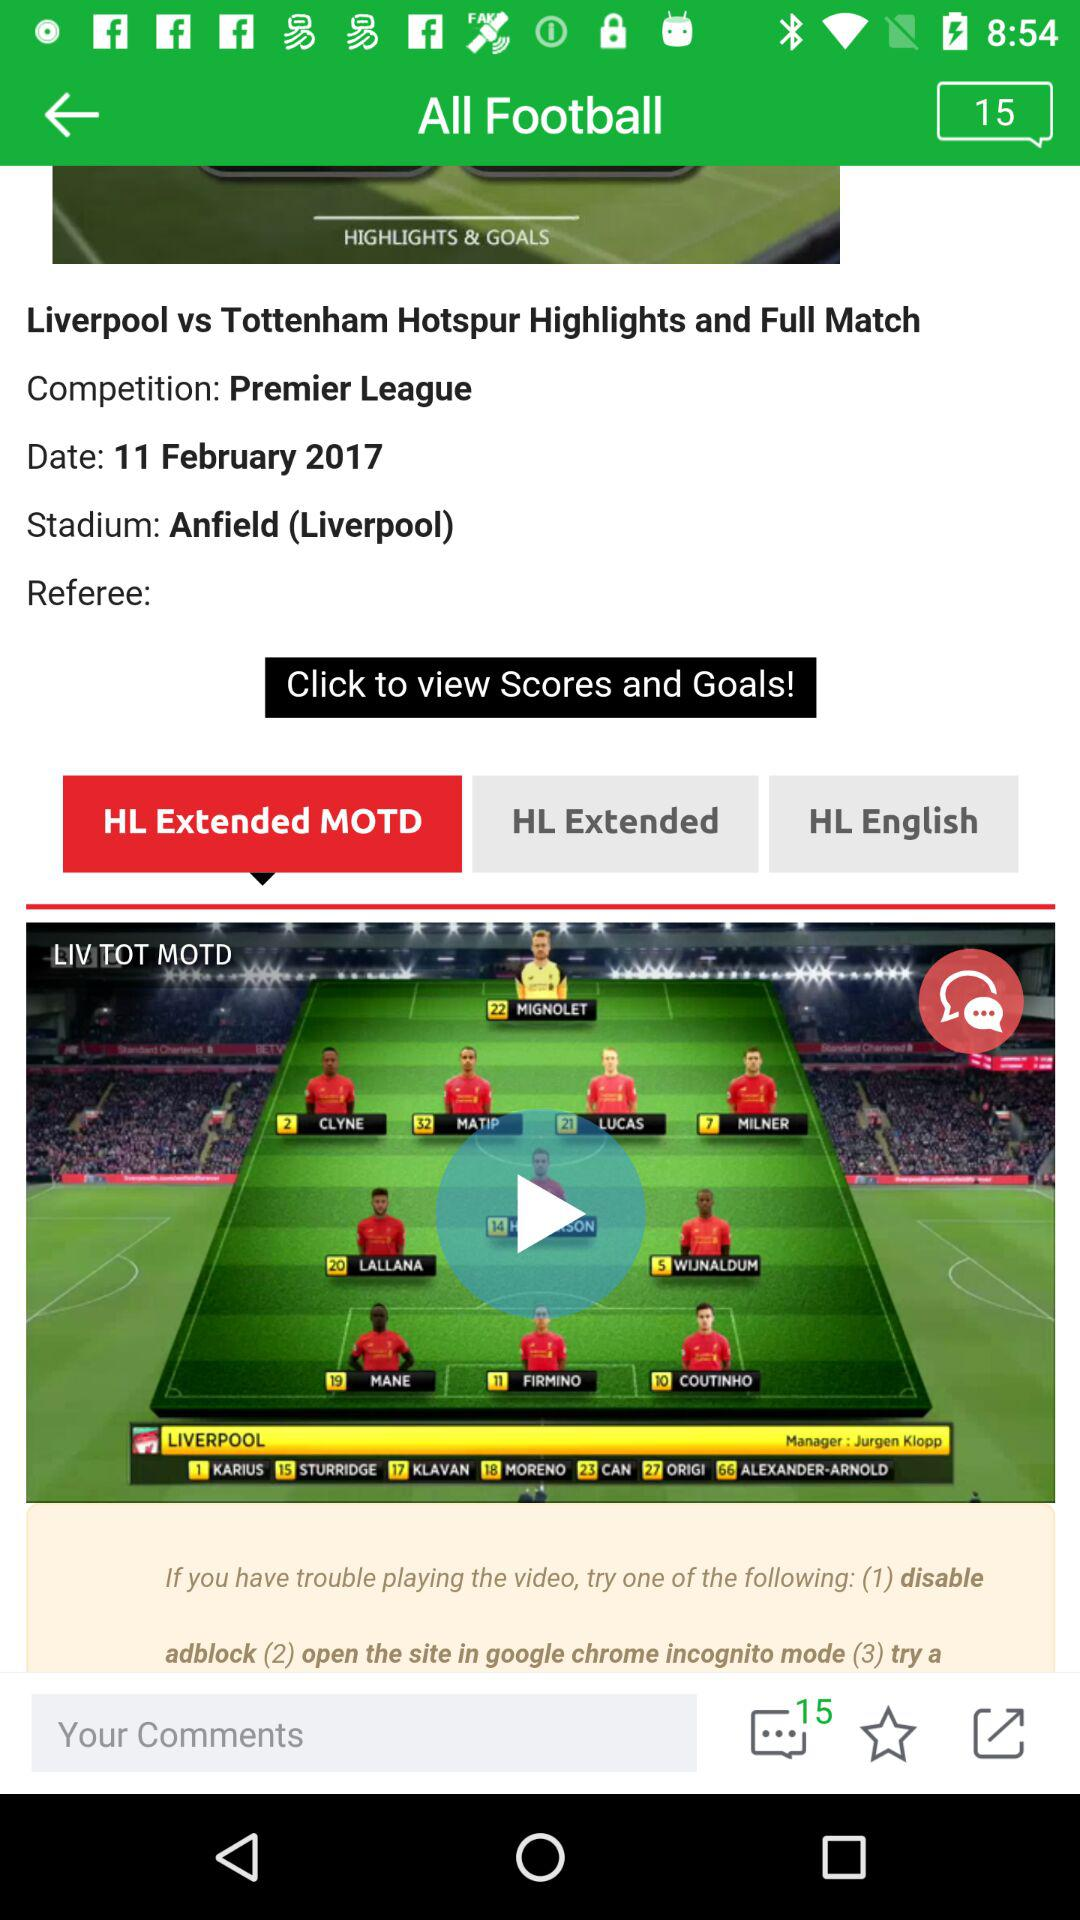How many unread comments are there? There are 15 unread comments. 